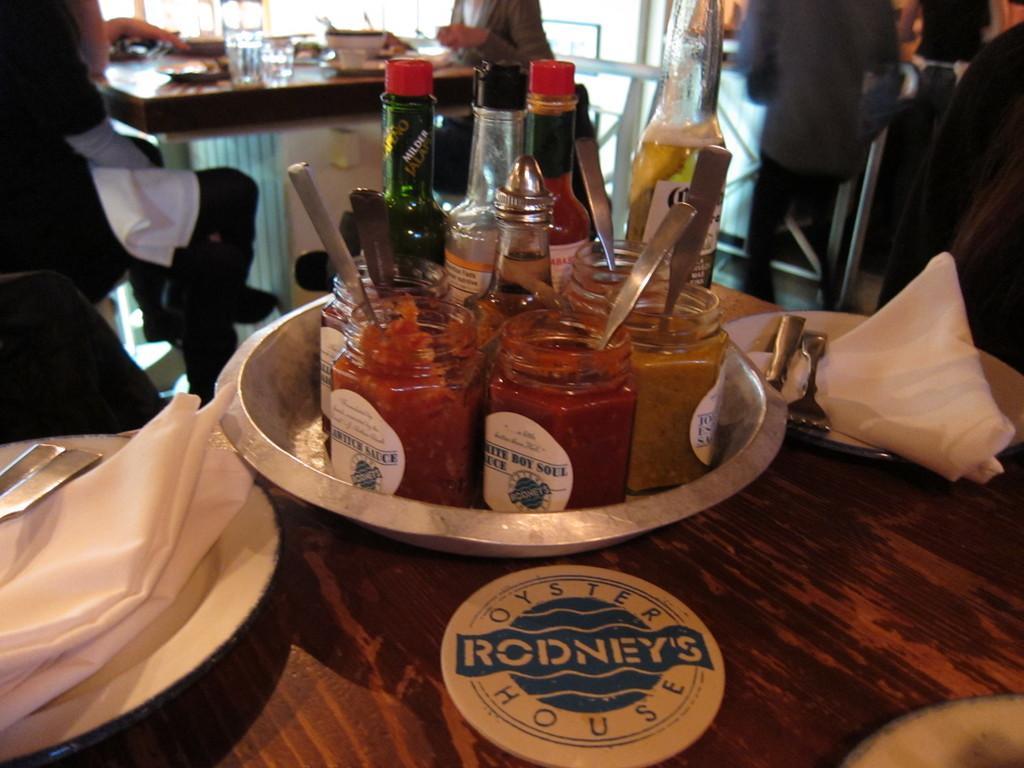Describe this image in one or two sentences. There is a table in the given picture on which some Bottles And a container were placed in the bowl. There is a plate in which form tissues and spoons were placed here on the table. In the background there are some people walking and some of them were sitting in front of a table on either sides. 